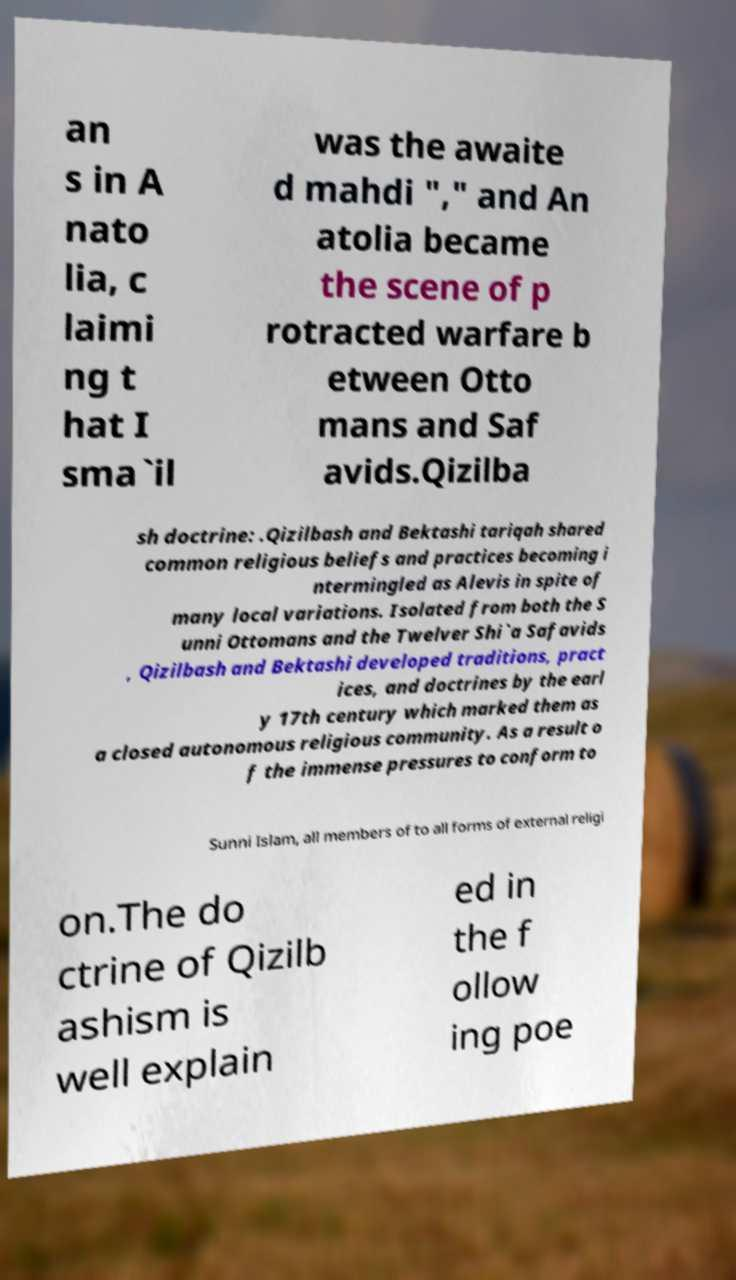Please read and relay the text visible in this image. What does it say? an s in A nato lia, c laimi ng t hat I sma`il was the awaite d mahdi "," and An atolia became the scene of p rotracted warfare b etween Otto mans and Saf avids.Qizilba sh doctrine: .Qizilbash and Bektashi tariqah shared common religious beliefs and practices becoming i ntermingled as Alevis in spite of many local variations. Isolated from both the S unni Ottomans and the Twelver Shi`a Safavids , Qizilbash and Bektashi developed traditions, pract ices, and doctrines by the earl y 17th century which marked them as a closed autonomous religious community. As a result o f the immense pressures to conform to Sunni Islam, all members of to all forms of external religi on.The do ctrine of Qizilb ashism is well explain ed in the f ollow ing poe 